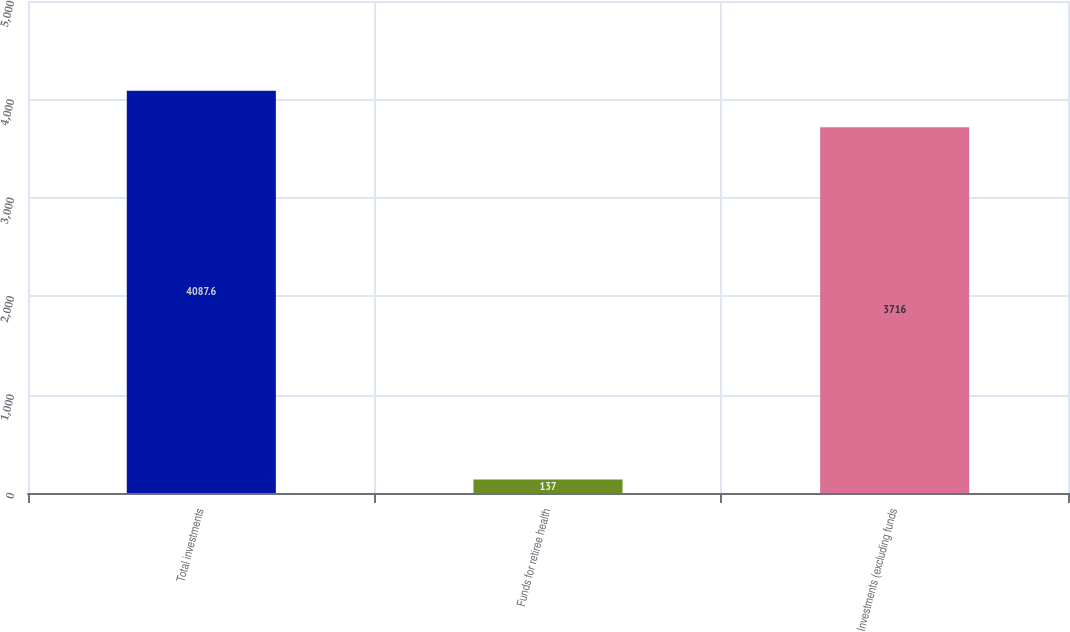<chart> <loc_0><loc_0><loc_500><loc_500><bar_chart><fcel>Total investments<fcel>Funds for retiree health<fcel>Investments (excluding funds<nl><fcel>4087.6<fcel>137<fcel>3716<nl></chart> 